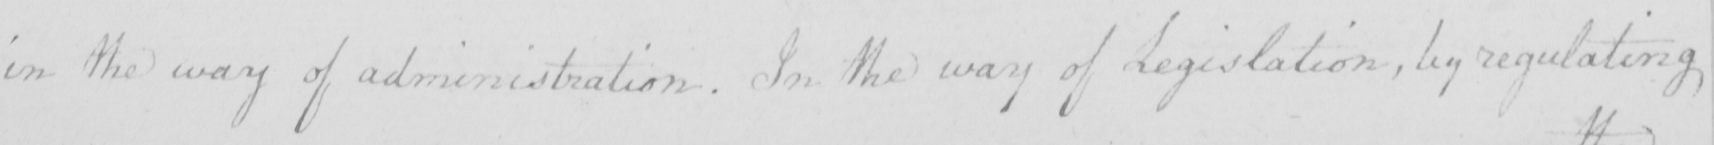What text is written in this handwritten line? in the way of administration . In the way of Legislation , by regulating 